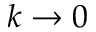<formula> <loc_0><loc_0><loc_500><loc_500>k \to 0</formula> 